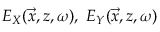Convert formula to latex. <formula><loc_0><loc_0><loc_500><loc_500>E _ { X } ( \vec { x } , z , \omega ) , E _ { Y } ( \vec { x } , z , \omega )</formula> 